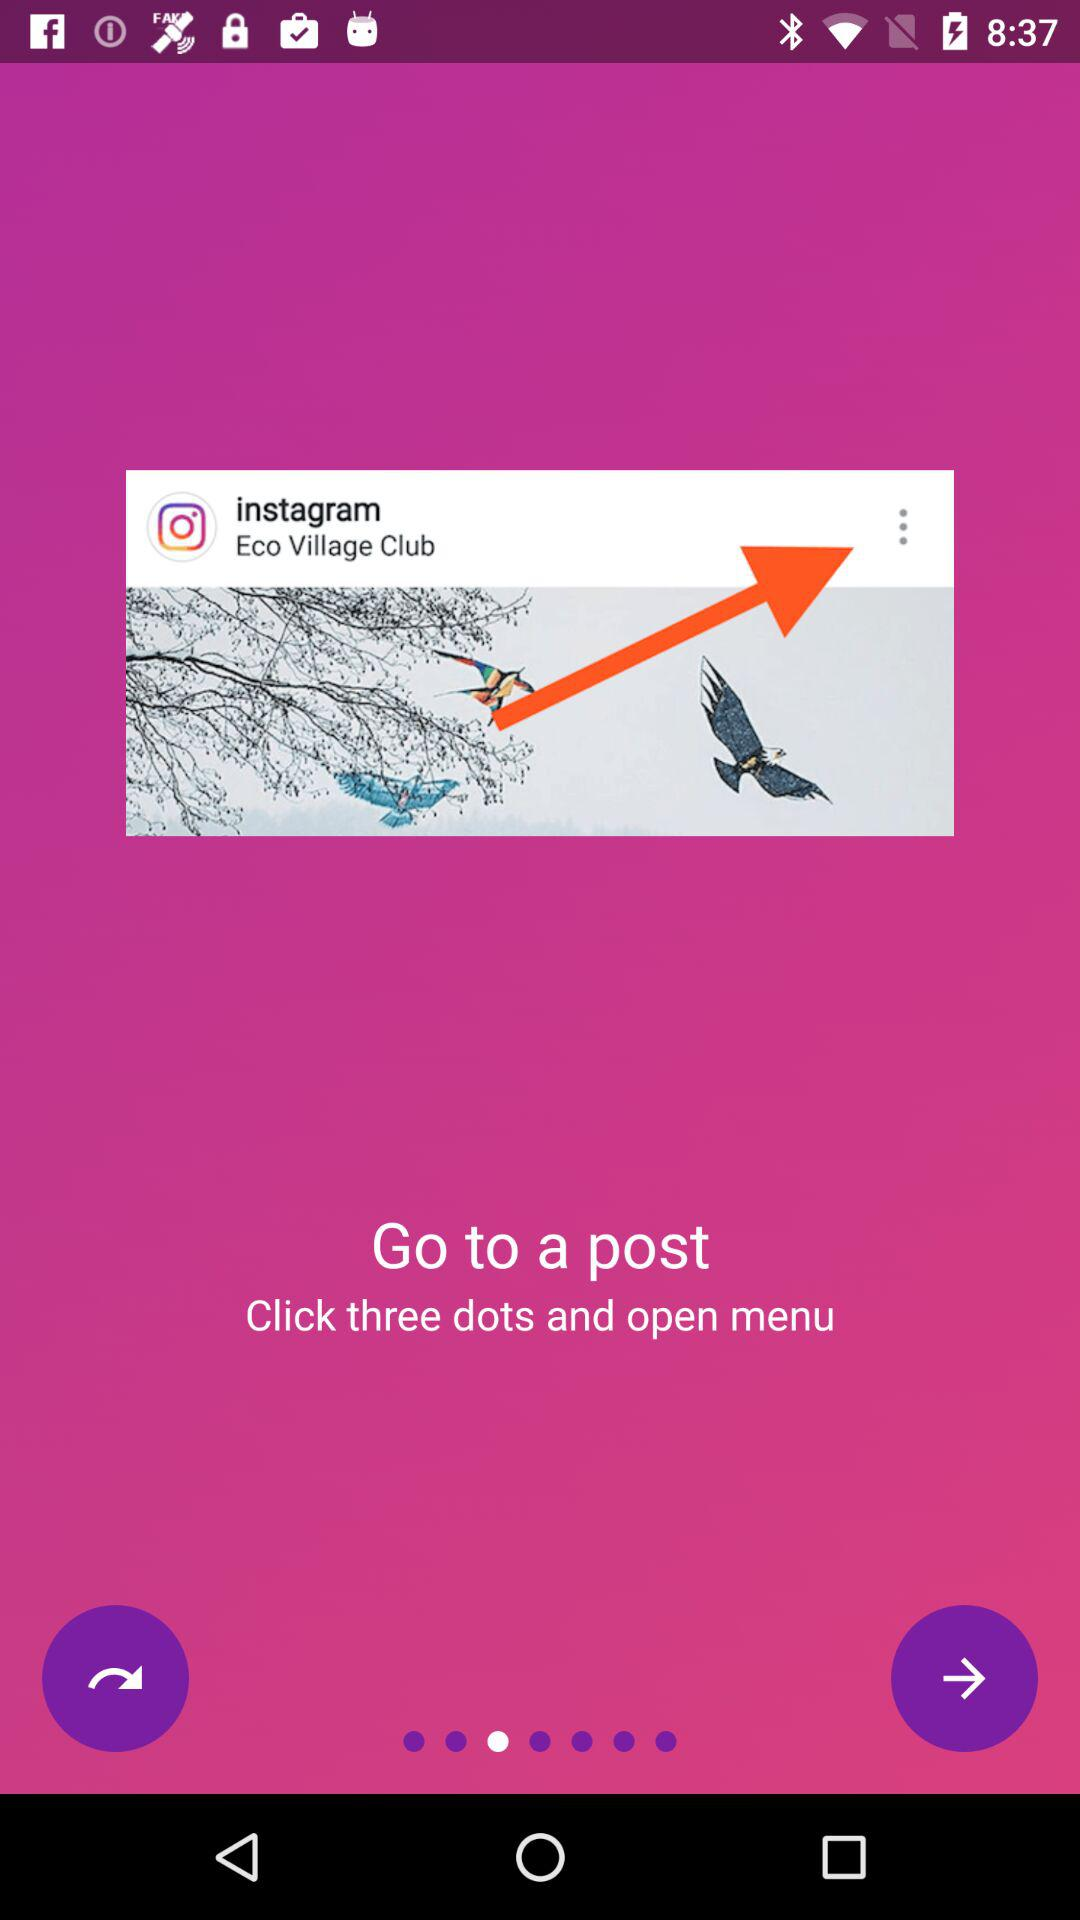What is the name of the application? The name of the application is "instagram". 